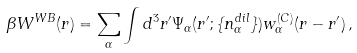<formula> <loc_0><loc_0><loc_500><loc_500>\beta W ^ { W B } ( { r } ) = \sum _ { \alpha } \int d ^ { 3 } r ^ { \prime } \Psi _ { \alpha } ( { r } ^ { \prime } ; \{ n _ { \alpha } ^ { d i l } \} ) w _ { \alpha } ^ { ( C ) } ( { r } - { r } ^ { \prime } ) \, ,</formula> 